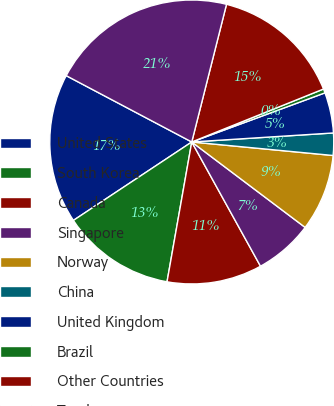Convert chart. <chart><loc_0><loc_0><loc_500><loc_500><pie_chart><fcel>United States<fcel>South Korea<fcel>Canada<fcel>Singapore<fcel>Norway<fcel>China<fcel>United Kingdom<fcel>Brazil<fcel>Other Countries<fcel>Total<nl><fcel>17.05%<fcel>12.9%<fcel>10.83%<fcel>6.68%<fcel>8.76%<fcel>2.53%<fcel>4.61%<fcel>0.46%<fcel>14.98%<fcel>21.2%<nl></chart> 